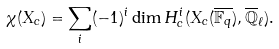<formula> <loc_0><loc_0><loc_500><loc_500>\chi ( X _ { c } ) = \sum _ { i } ( - 1 ) ^ { i } \dim H _ { c } ^ { i } ( X _ { c } ( \overline { \mathbb { F } _ { q } } ) , \overline { \mathbb { Q } } _ { \ell } ) .</formula> 